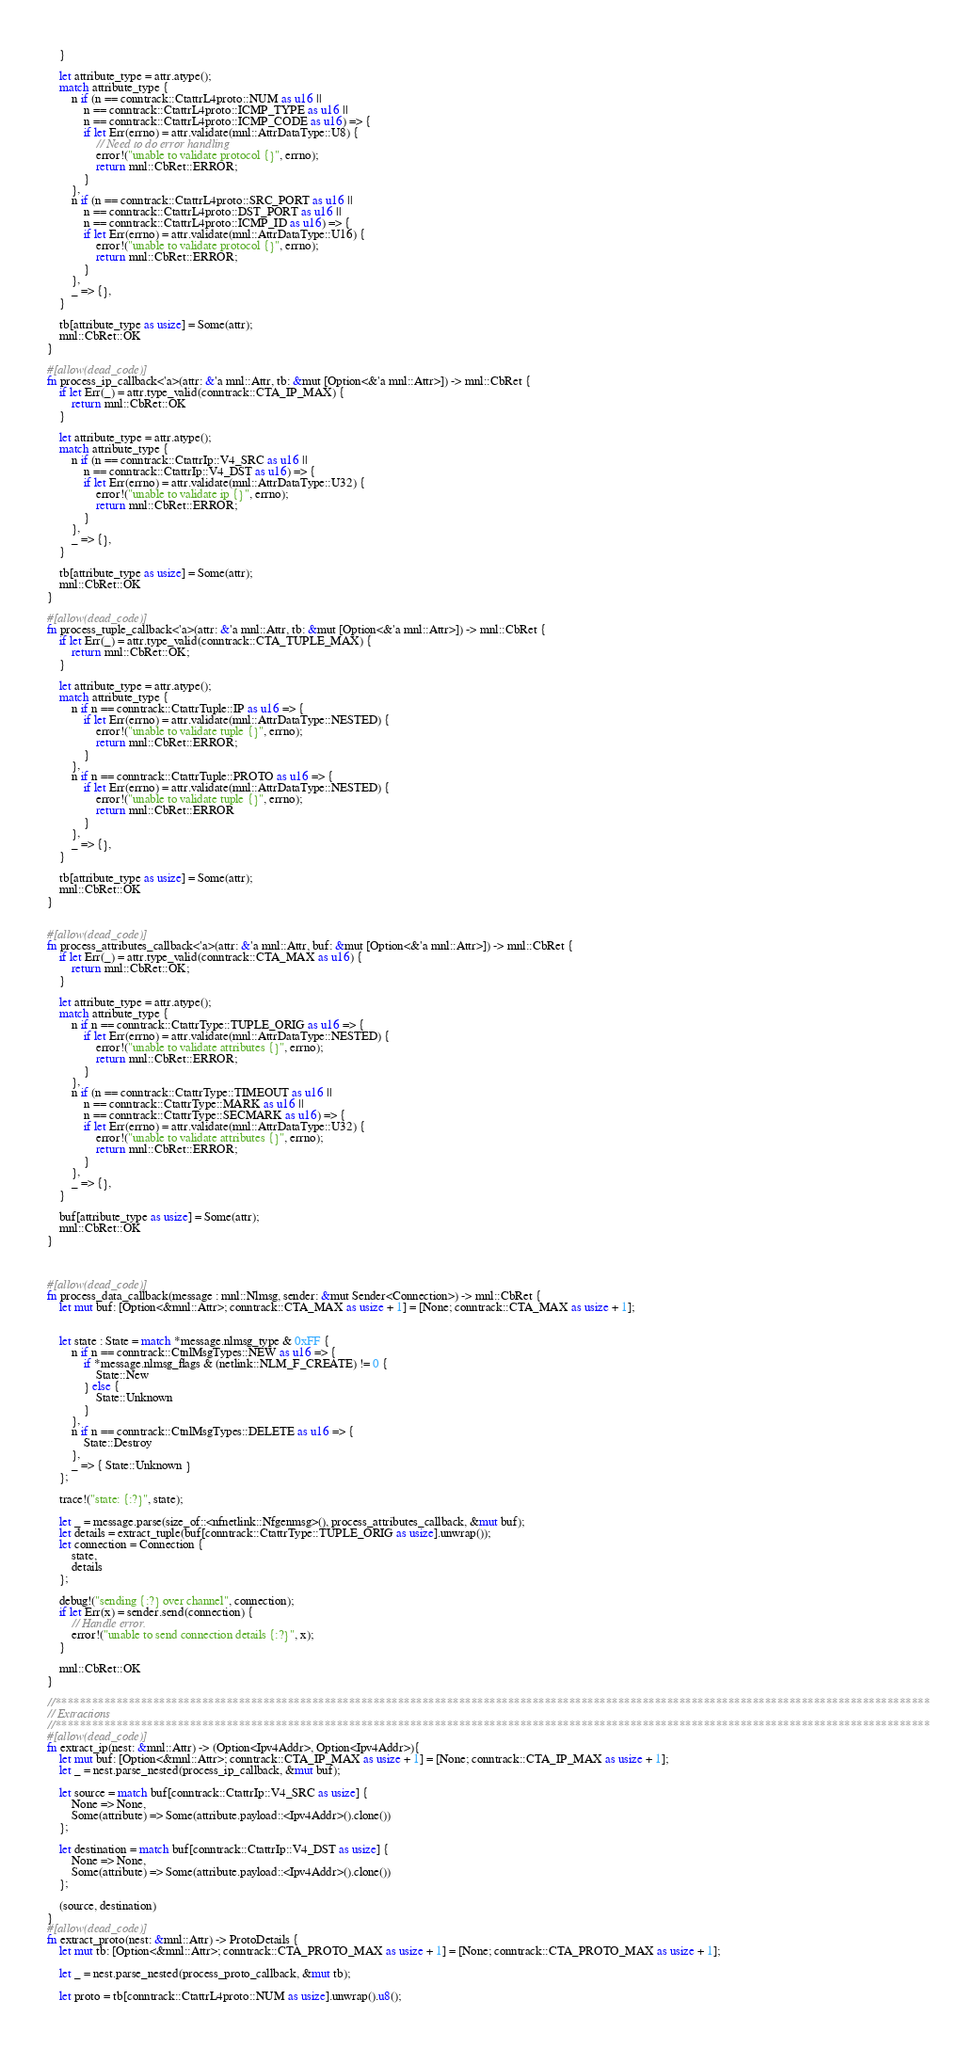<code> <loc_0><loc_0><loc_500><loc_500><_Rust_>    }

    let attribute_type = attr.atype();
    match attribute_type {
        n if (n == conntrack::CtattrL4proto::NUM as u16 ||
            n == conntrack::CtattrL4proto::ICMP_TYPE as u16 ||
            n == conntrack::CtattrL4proto::ICMP_CODE as u16) => {
            if let Err(errno) = attr.validate(mnl::AttrDataType::U8) {
                // Need to do error handling
                error!("unable to validate protocol {}", errno);
                return mnl::CbRet::ERROR;
            }
        },
        n if (n == conntrack::CtattrL4proto::SRC_PORT as u16 ||
            n == conntrack::CtattrL4proto::DST_PORT as u16 ||
            n == conntrack::CtattrL4proto::ICMP_ID as u16) => {
            if let Err(errno) = attr.validate(mnl::AttrDataType::U16) {
                error!("unable to validate protocol {}", errno);
                return mnl::CbRet::ERROR;
            }
        },
        _ => {},
    }

    tb[attribute_type as usize] = Some(attr);
    mnl::CbRet::OK
}

#[allow(dead_code)]
fn process_ip_callback<'a>(attr: &'a mnl::Attr, tb: &mut [Option<&'a mnl::Attr>]) -> mnl::CbRet {
    if let Err(_) = attr.type_valid(conntrack::CTA_IP_MAX) {
        return mnl::CbRet::OK
    }

    let attribute_type = attr.atype();
    match attribute_type {
        n if (n == conntrack::CtattrIp::V4_SRC as u16 ||
            n == conntrack::CtattrIp::V4_DST as u16) => {
            if let Err(errno) = attr.validate(mnl::AttrDataType::U32) {
                error!("unable to validate ip {}", errno);
                return mnl::CbRet::ERROR;
            }
        },
        _ => {},
    }

    tb[attribute_type as usize] = Some(attr);
    mnl::CbRet::OK
}

#[allow(dead_code)]
fn process_tuple_callback<'a>(attr: &'a mnl::Attr, tb: &mut [Option<&'a mnl::Attr>]) -> mnl::CbRet {
    if let Err(_) = attr.type_valid(conntrack::CTA_TUPLE_MAX) {
        return mnl::CbRet::OK;
    }

    let attribute_type = attr.atype();
    match attribute_type {
        n if n == conntrack::CtattrTuple::IP as u16 => {
            if let Err(errno) = attr.validate(mnl::AttrDataType::NESTED) {
                error!("unable to validate tuple {}", errno);
                return mnl::CbRet::ERROR;
            }
        },
        n if n == conntrack::CtattrTuple::PROTO as u16 => {
            if let Err(errno) = attr.validate(mnl::AttrDataType::NESTED) {
                error!("unable to validate tuple {}", errno);
                return mnl::CbRet::ERROR
            }
        },
        _ => {},
    }

    tb[attribute_type as usize] = Some(attr);
    mnl::CbRet::OK
}


#[allow(dead_code)]
fn process_attributes_callback<'a>(attr: &'a mnl::Attr, buf: &mut [Option<&'a mnl::Attr>]) -> mnl::CbRet {
    if let Err(_) = attr.type_valid(conntrack::CTA_MAX as u16) {
        return mnl::CbRet::OK;
    }

    let attribute_type = attr.atype();
    match attribute_type {
        n if n == conntrack::CtattrType::TUPLE_ORIG as u16 => {
            if let Err(errno) = attr.validate(mnl::AttrDataType::NESTED) {
                error!("unable to validate attributes {}", errno);
                return mnl::CbRet::ERROR;
            }
        },
        n if (n == conntrack::CtattrType::TIMEOUT as u16 ||
            n == conntrack::CtattrType::MARK as u16 ||
            n == conntrack::CtattrType::SECMARK as u16) => {
            if let Err(errno) = attr.validate(mnl::AttrDataType::U32) {
                error!("unable to validate attributes {}", errno);
                return mnl::CbRet::ERROR;
            }
        },
        _ => {},
    }

    buf[attribute_type as usize] = Some(attr);
    mnl::CbRet::OK
}



#[allow(dead_code)]
fn process_data_callback(message : mnl::Nlmsg, sender: &mut Sender<Connection>) -> mnl::CbRet {
    let mut buf: [Option<&mnl::Attr>; conntrack::CTA_MAX as usize + 1] = [None; conntrack::CTA_MAX as usize + 1];


    let state : State = match *message.nlmsg_type & 0xFF {
        n if n == conntrack::CtnlMsgTypes::NEW as u16 => {
            if *message.nlmsg_flags & (netlink::NLM_F_CREATE) != 0 {
                State::New
            } else {
                State::Unknown
            }
        },
        n if n == conntrack::CtnlMsgTypes::DELETE as u16 => {
            State::Destroy
        },
        _ => { State::Unknown }
    };

    trace!("state: {:?}", state);

    let _ = message.parse(size_of::<nfnetlink::Nfgenmsg>(), process_attributes_callback, &mut buf);
    let details = extract_tuple(buf[conntrack::CtattrType::TUPLE_ORIG as usize].unwrap());
    let connection = Connection {
        state,
        details
    };

    debug!("sending {:?} over channel", connection);
    if let Err(x) = sender.send(connection) {
        // Handle error.
        error!("unable to send connection details {:?}", x);
    }

    mnl::CbRet::OK
}

//***********************************************************************************************************************************************
// Extractions
//***********************************************************************************************************************************************
#[allow(dead_code)]
fn extract_ip(nest: &mnl::Attr) -> (Option<Ipv4Addr>, Option<Ipv4Addr>){
    let mut buf: [Option<&mnl::Attr>; conntrack::CTA_IP_MAX as usize + 1] = [None; conntrack::CTA_IP_MAX as usize + 1];
    let _ = nest.parse_nested(process_ip_callback, &mut buf);

    let source = match buf[conntrack::CtattrIp::V4_SRC as usize] {
        None => None,
        Some(attribute) => Some(attribute.payload::<Ipv4Addr>().clone())
    };

    let destination = match buf[conntrack::CtattrIp::V4_DST as usize] {
        None => None,
        Some(attribute) => Some(attribute.payload::<Ipv4Addr>().clone())
    };

    (source, destination)
}
#[allow(dead_code)]
fn extract_proto(nest: &mnl::Attr) -> ProtoDetails {
    let mut tb: [Option<&mnl::Attr>; conntrack::CTA_PROTO_MAX as usize + 1] = [None; conntrack::CTA_PROTO_MAX as usize + 1];

    let _ = nest.parse_nested(process_proto_callback, &mut tb);

    let proto = tb[conntrack::CtattrL4proto::NUM as usize].unwrap().u8();
</code> 